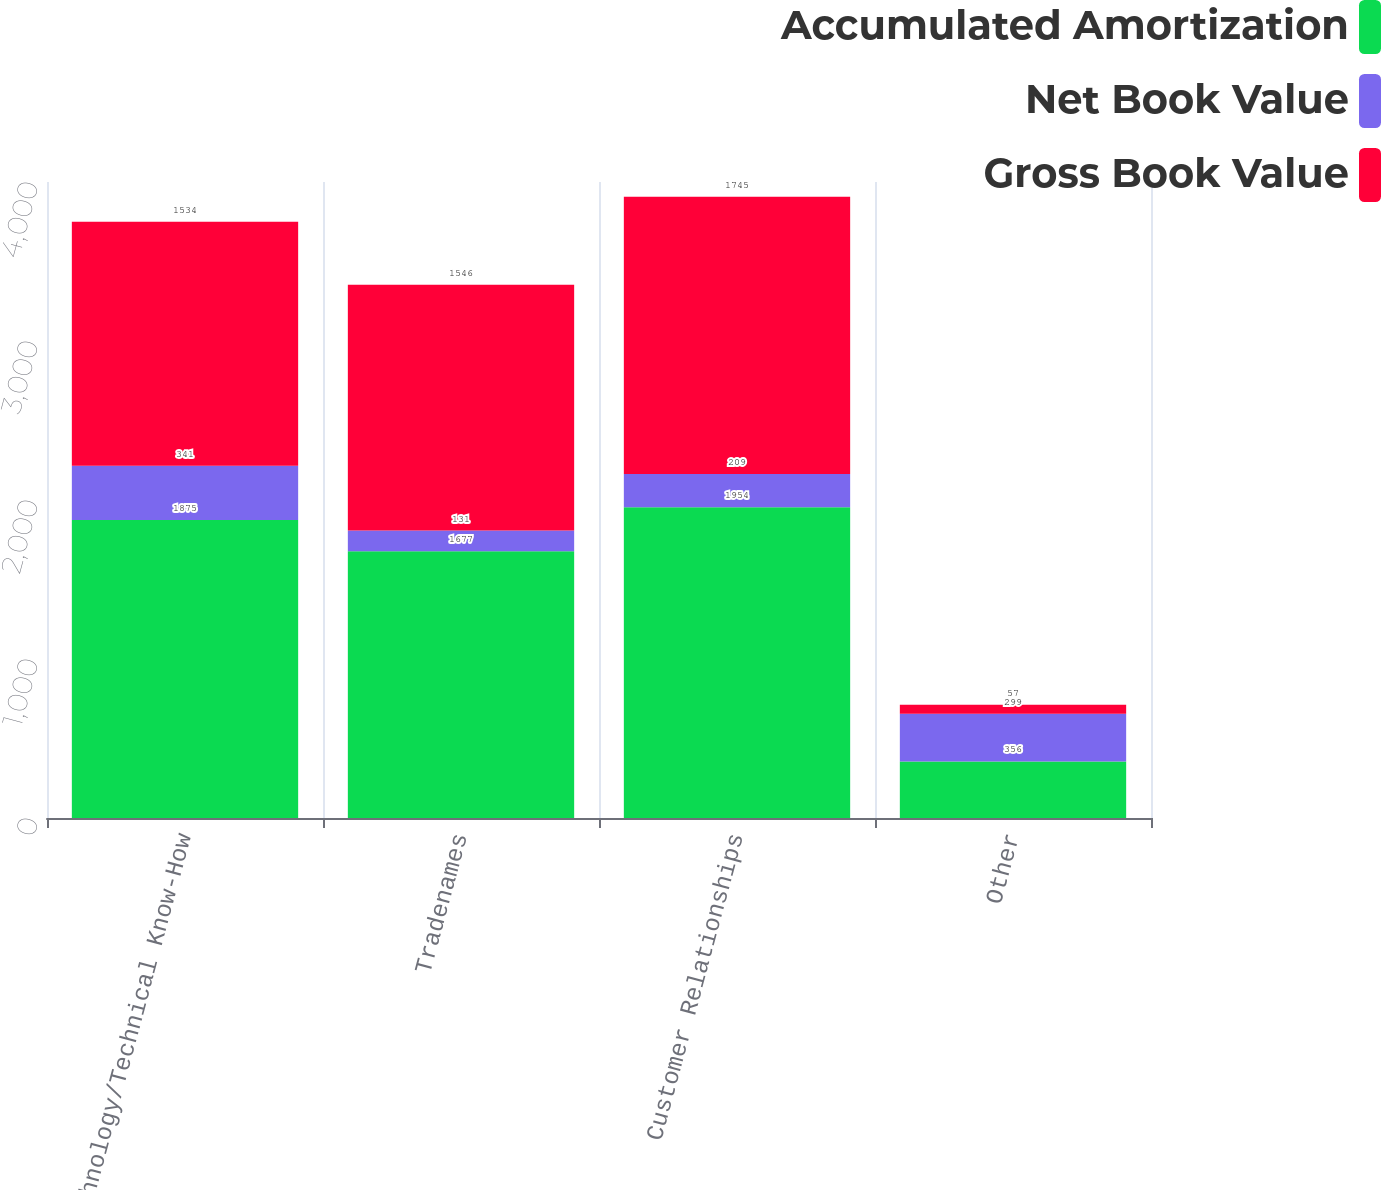Convert chart to OTSL. <chart><loc_0><loc_0><loc_500><loc_500><stacked_bar_chart><ecel><fcel>Technology/Technical Know-How<fcel>Tradenames<fcel>Customer Relationships<fcel>Other<nl><fcel>Accumulated Amortization<fcel>1875<fcel>1677<fcel>1954<fcel>356<nl><fcel>Net Book Value<fcel>341<fcel>131<fcel>209<fcel>299<nl><fcel>Gross Book Value<fcel>1534<fcel>1546<fcel>1745<fcel>57<nl></chart> 